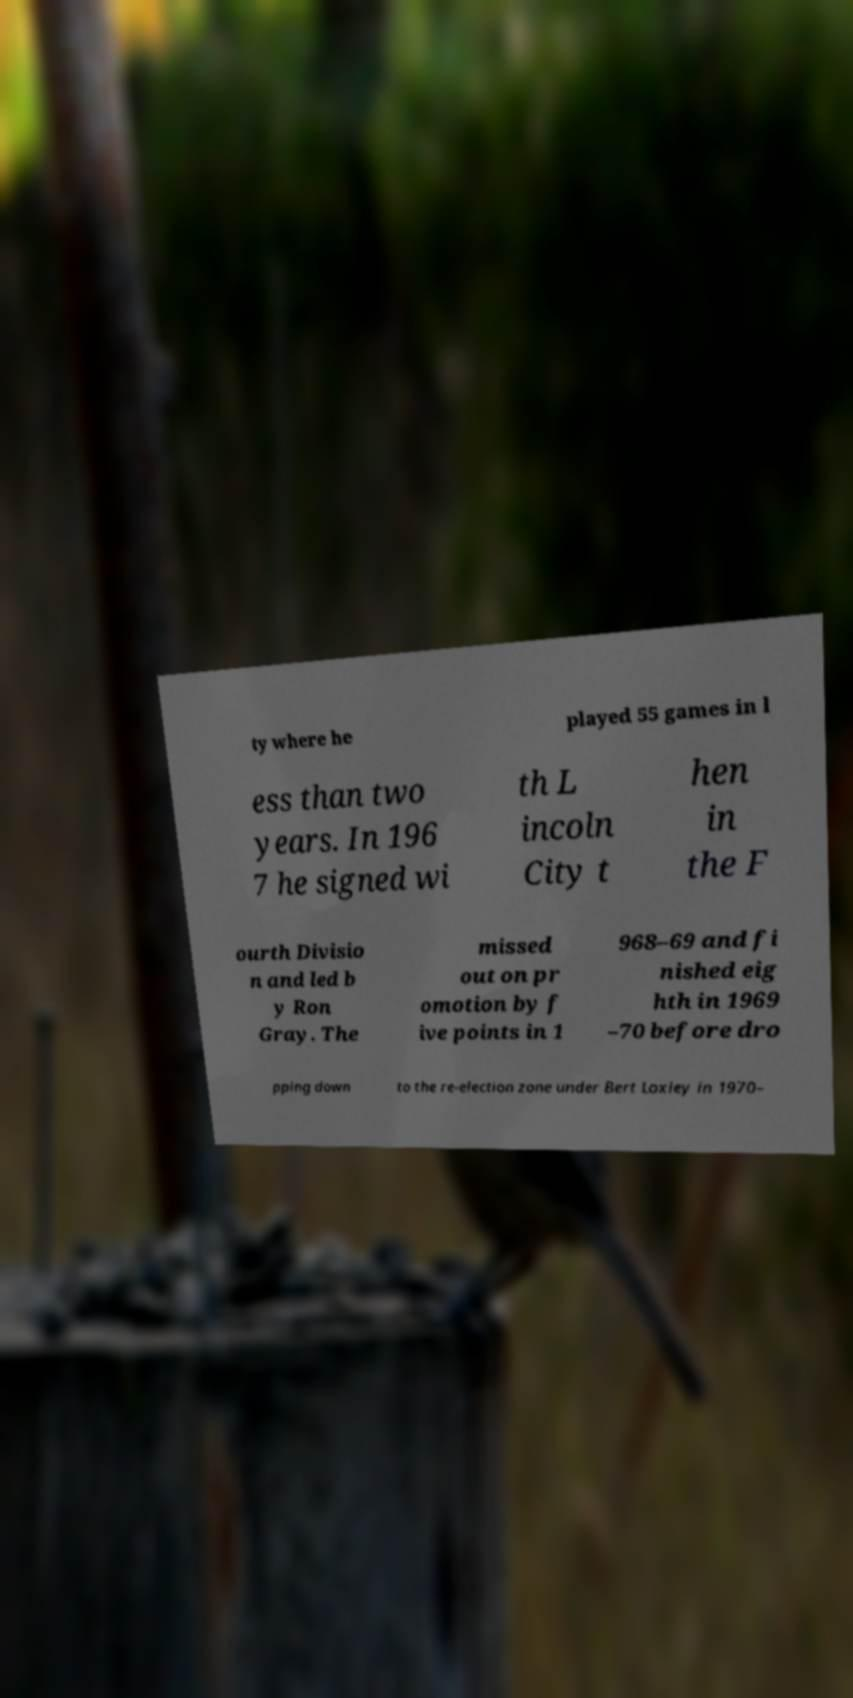For documentation purposes, I need the text within this image transcribed. Could you provide that? ty where he played 55 games in l ess than two years. In 196 7 he signed wi th L incoln City t hen in the F ourth Divisio n and led b y Ron Gray. The missed out on pr omotion by f ive points in 1 968–69 and fi nished eig hth in 1969 –70 before dro pping down to the re-election zone under Bert Loxley in 1970– 